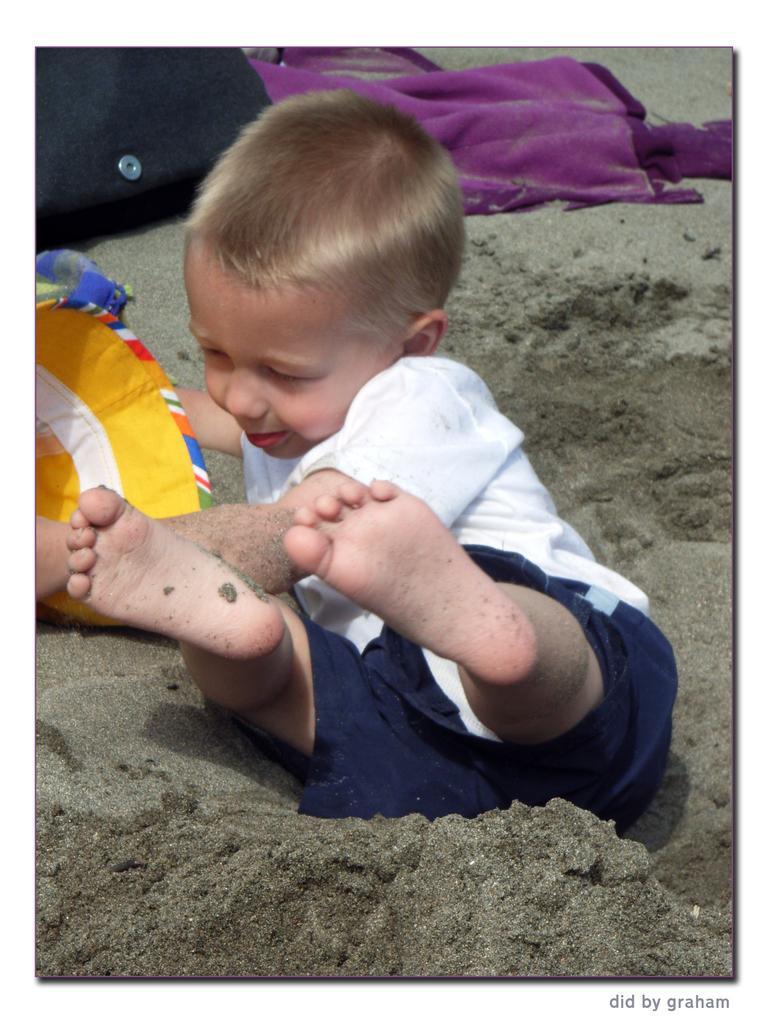How would you summarize this image in a sentence or two? This image consists of a kid. He is wearing a white shirt. There is a cloth at the top. There is sand in this image. 